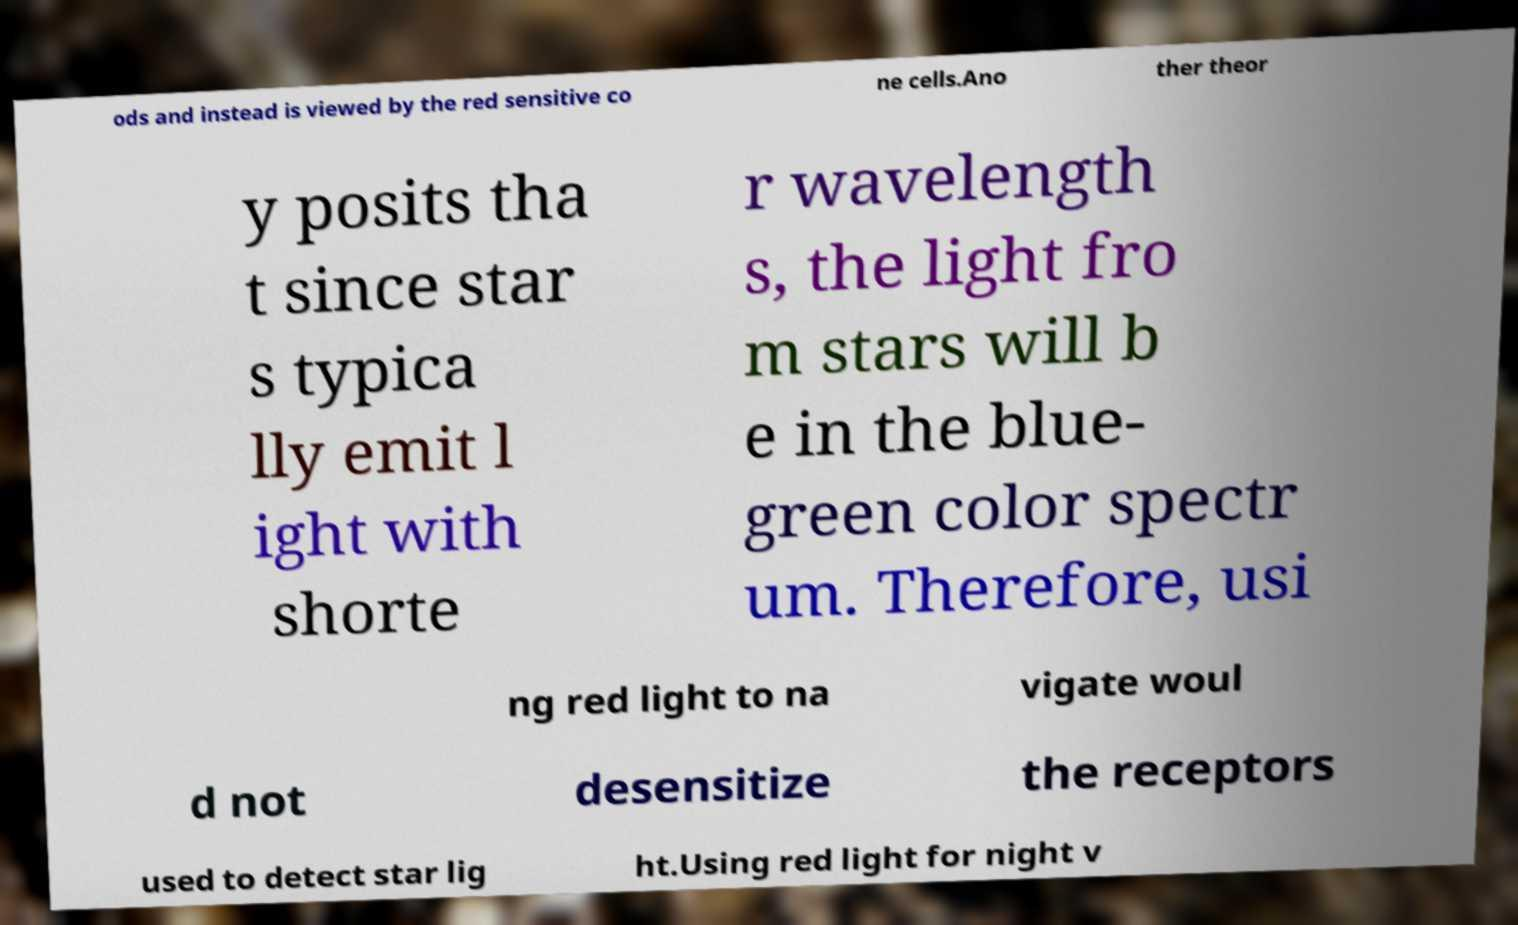Can you read and provide the text displayed in the image?This photo seems to have some interesting text. Can you extract and type it out for me? ods and instead is viewed by the red sensitive co ne cells.Ano ther theor y posits tha t since star s typica lly emit l ight with shorte r wavelength s, the light fro m stars will b e in the blue- green color spectr um. Therefore, usi ng red light to na vigate woul d not desensitize the receptors used to detect star lig ht.Using red light for night v 